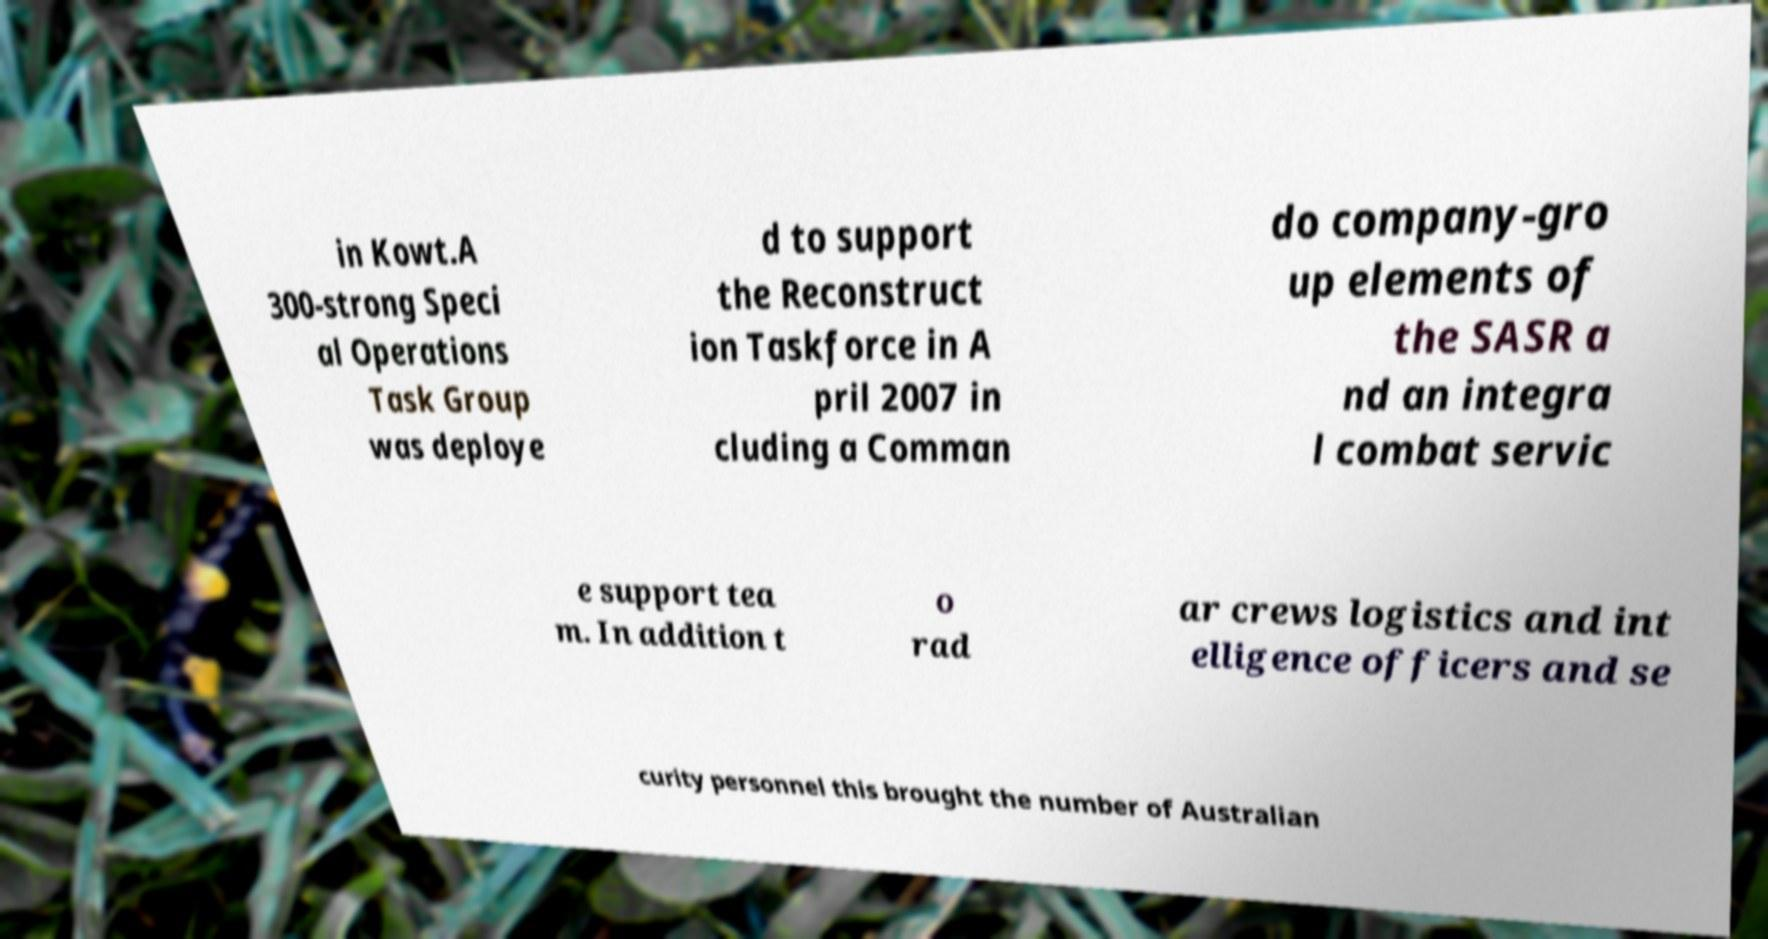Could you extract and type out the text from this image? in Kowt.A 300-strong Speci al Operations Task Group was deploye d to support the Reconstruct ion Taskforce in A pril 2007 in cluding a Comman do company-gro up elements of the SASR a nd an integra l combat servic e support tea m. In addition t o rad ar crews logistics and int elligence officers and se curity personnel this brought the number of Australian 